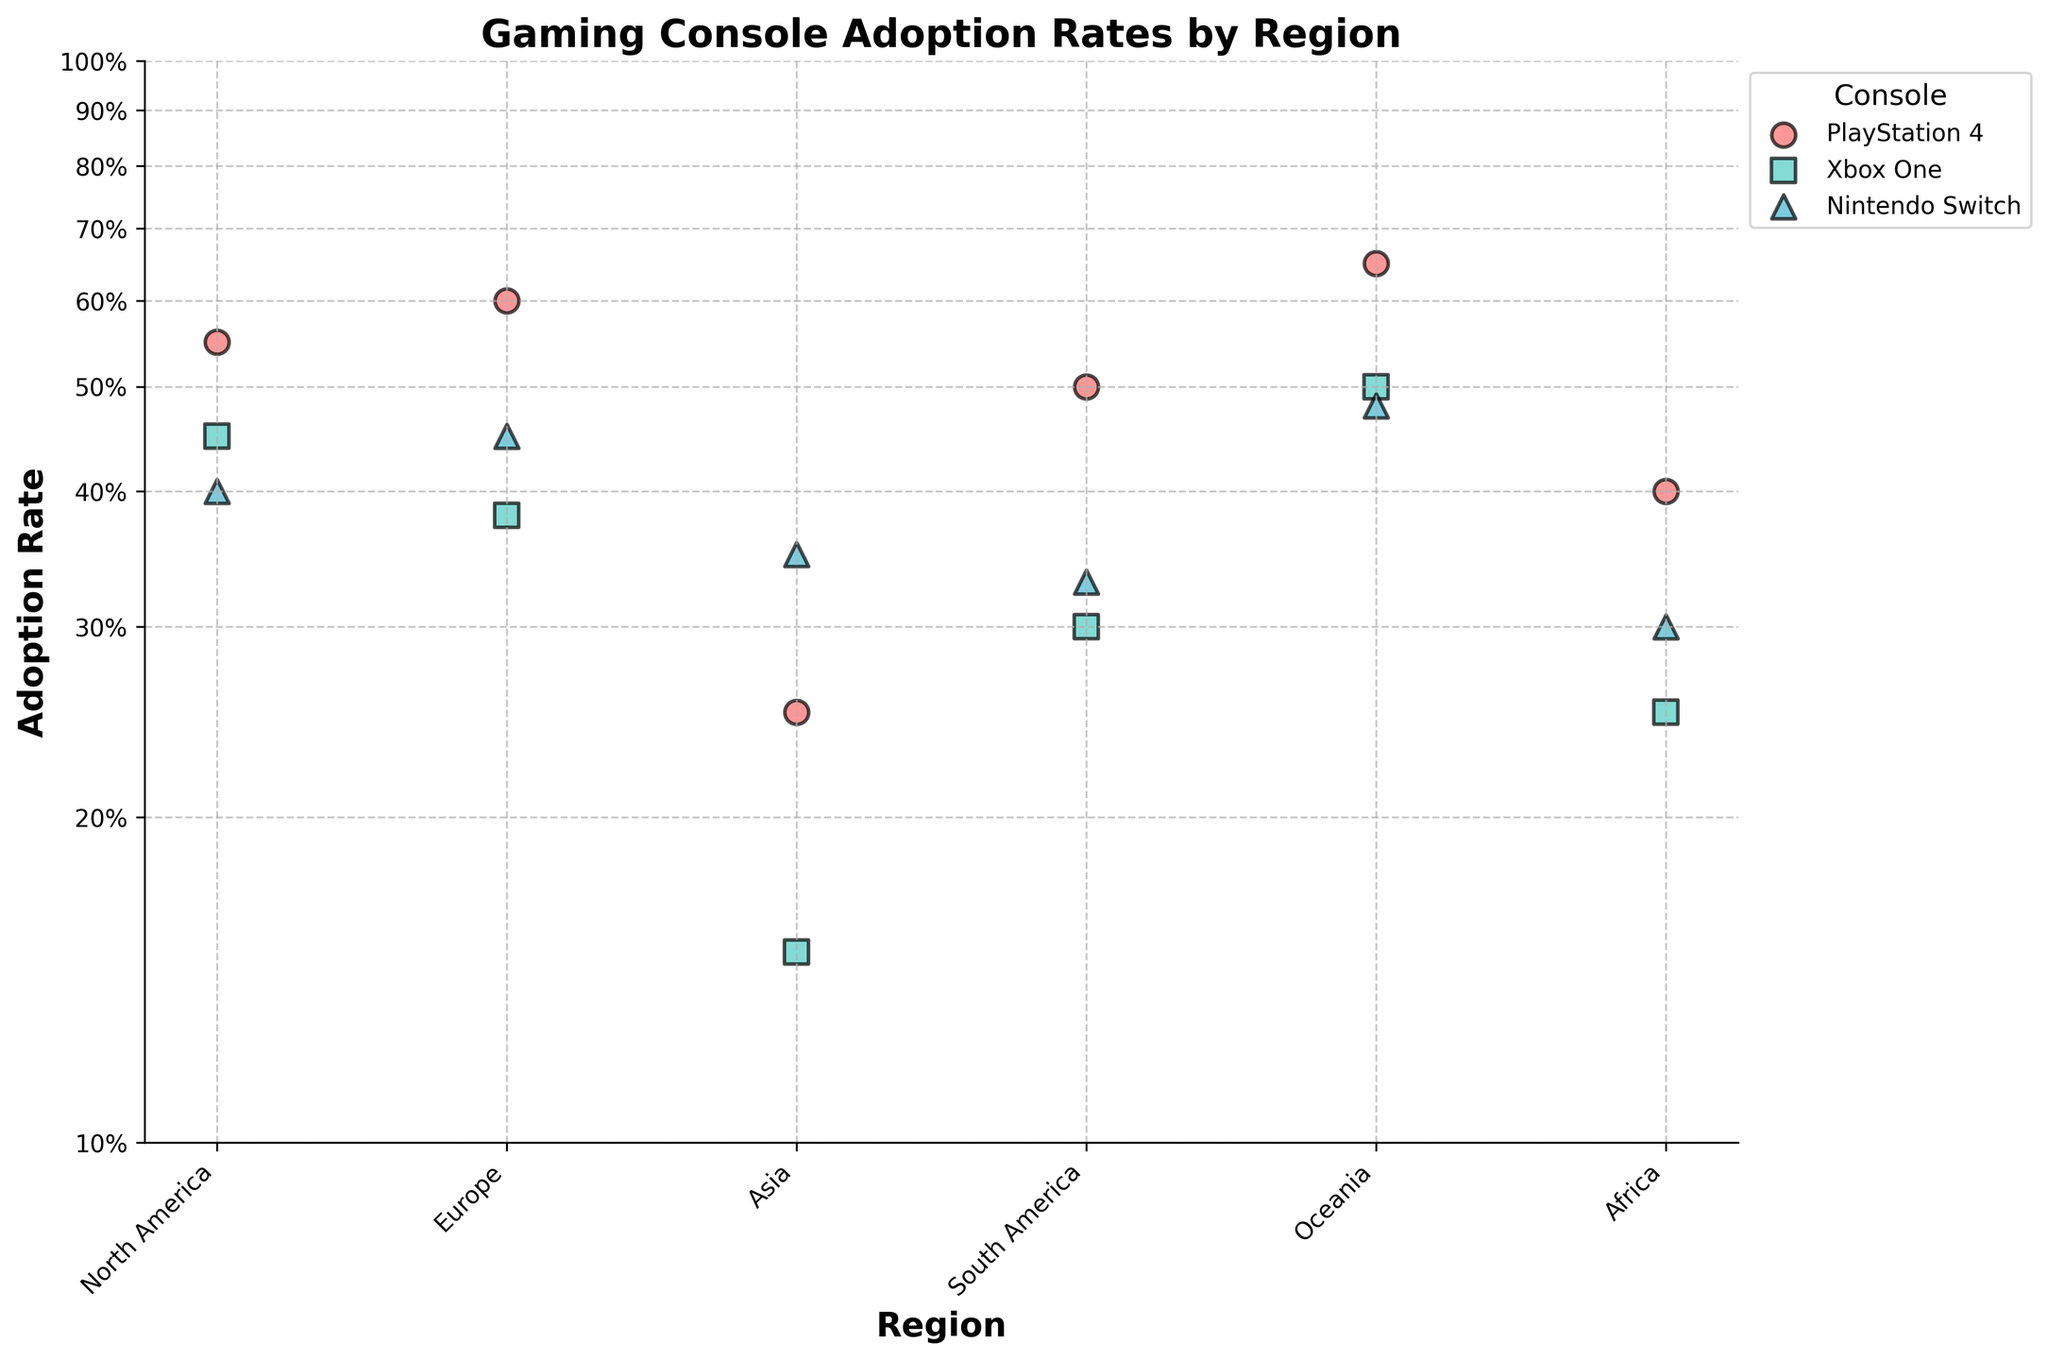What is the title of the scatter plot? The title is typically displayed prominently above the plot. In this case, it states the purpose of the plot.
Answer: Gaming Console Adoption Rates by Region Which console has the highest adoption rate in Europe? By looking at the data points labeled "Europe," the PlayStation 4 has an adoption rate at the upper end (0.60).
Answer: PlayStation 4 How many consoles are represented in the plot? Each console is labeled along with its adoption rate, and there are three different symbols/colors representing different consoles.
Answer: Three Which region has the lowest adoption rate for the Xbox One? By observing the Xbox One data points across all regions, the point in Asia represents the lowest rate (0.15).
Answer: Asia How does the adoption rate of PlayStation 4 in North America compare to that in Asia? Look at the two data points for PlayStation 4 in North America (0.55) and Asia (0.25). Compare these values directly.
Answer: Higher in North America Which console has the smallest range of adoption rates across all regions? Identify the maximum and minimum adoption rates for each console and compare these ranges. The Xbox One has the smallest range from 0.15 to 0.50 (spread of 0.35).
Answer: Xbox One What is the difference in adoption rates of Nintendo Switch between North America and Asia? Subtract the adoption rate in Asia (0.35) from that in North America (0.40): 0.40 - 0.35.
Answer: 0.05 or 5% Which region has the highest overall adoption rate of any console? By scanning the y-axis values, the highest adoption rate is found in Oceania for the PlayStation 4 (0.65).
Answer: Oceania Which console shows the highest adoption rate in Africa? Look for the highest data point labeled "Africa" and find it corresponds to PlayStation 4 with a value of 0.40.
Answer: PlayStation 4 